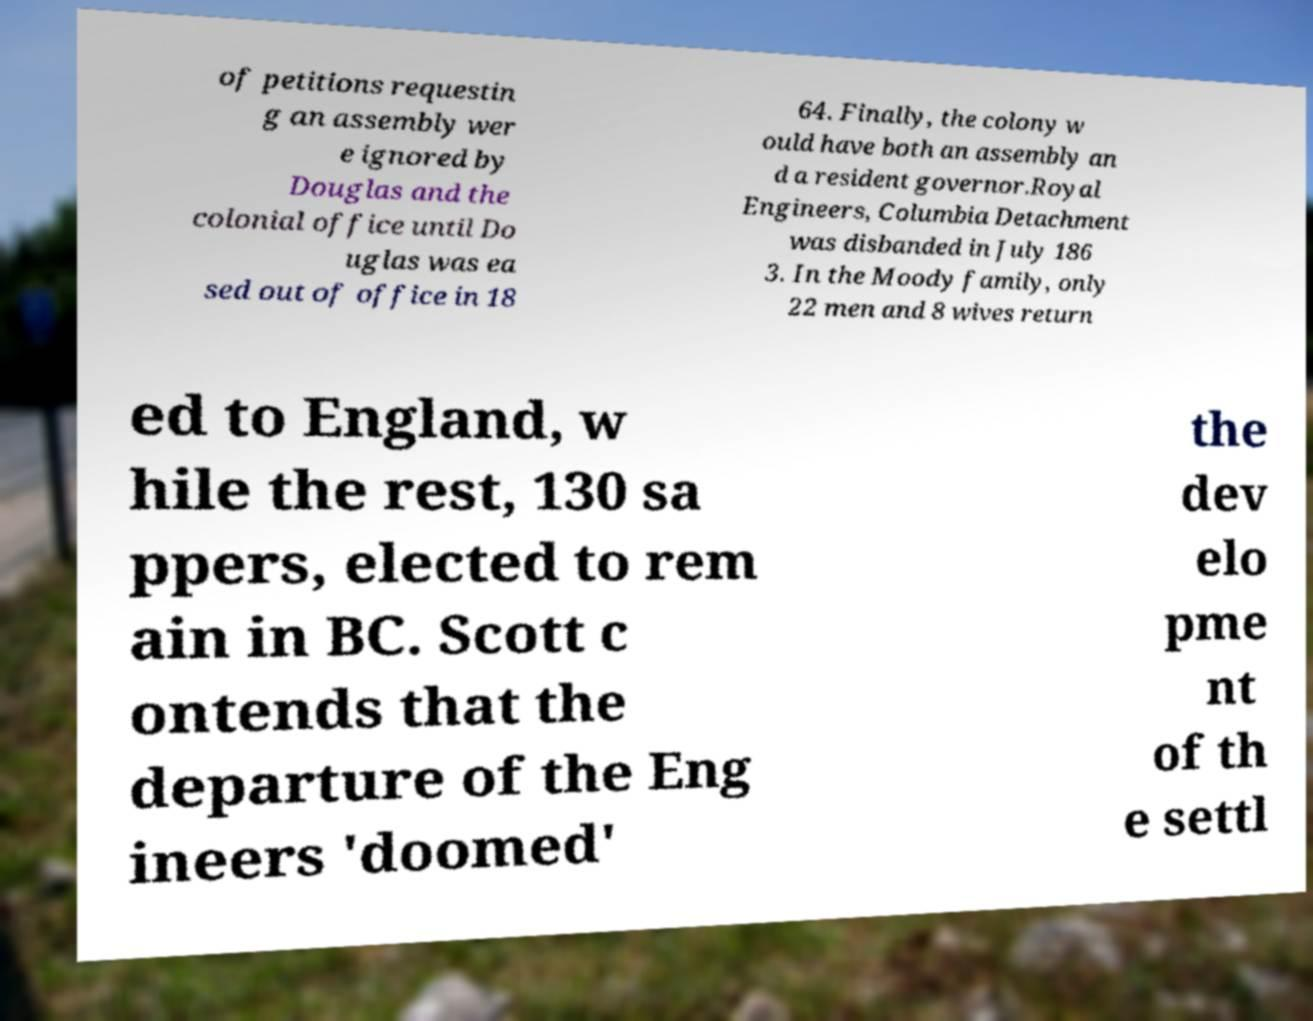There's text embedded in this image that I need extracted. Can you transcribe it verbatim? of petitions requestin g an assembly wer e ignored by Douglas and the colonial office until Do uglas was ea sed out of office in 18 64. Finally, the colony w ould have both an assembly an d a resident governor.Royal Engineers, Columbia Detachment was disbanded in July 186 3. In the Moody family, only 22 men and 8 wives return ed to England, w hile the rest, 130 sa ppers, elected to rem ain in BC. Scott c ontends that the departure of the Eng ineers 'doomed' the dev elo pme nt of th e settl 